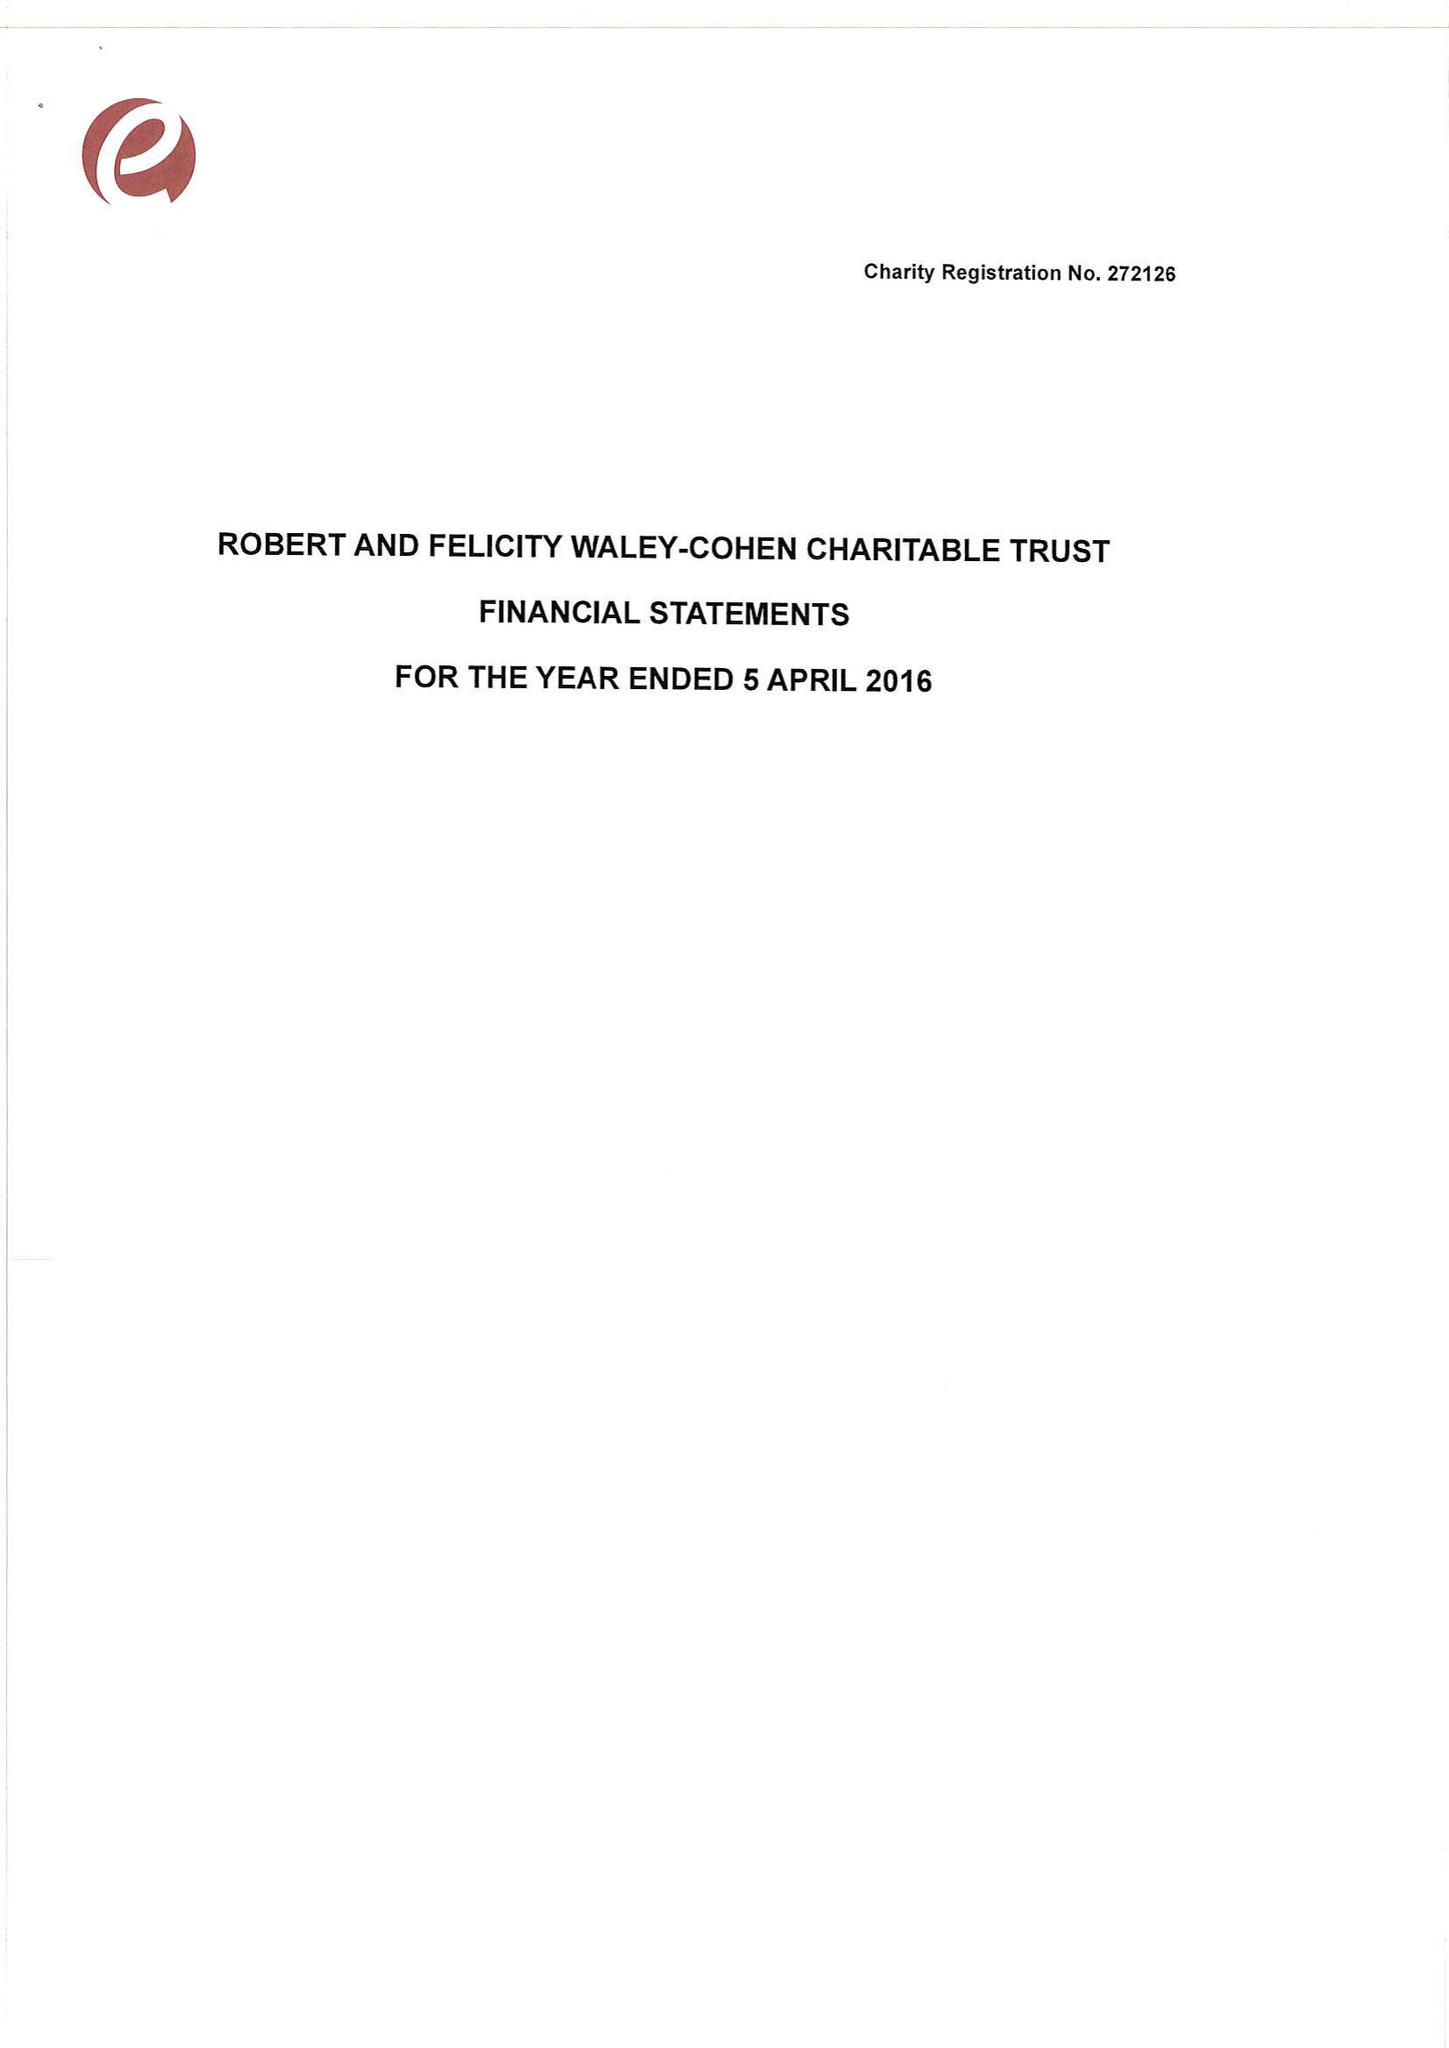What is the value for the address__street_line?
Answer the question using a single word or phrase. 27 SOUTH TERRACE 